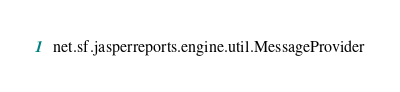Convert code to text. <code><loc_0><loc_0><loc_500><loc_500><_Rust_>net.sf.jasperreports.engine.util.MessageProvider
</code> 